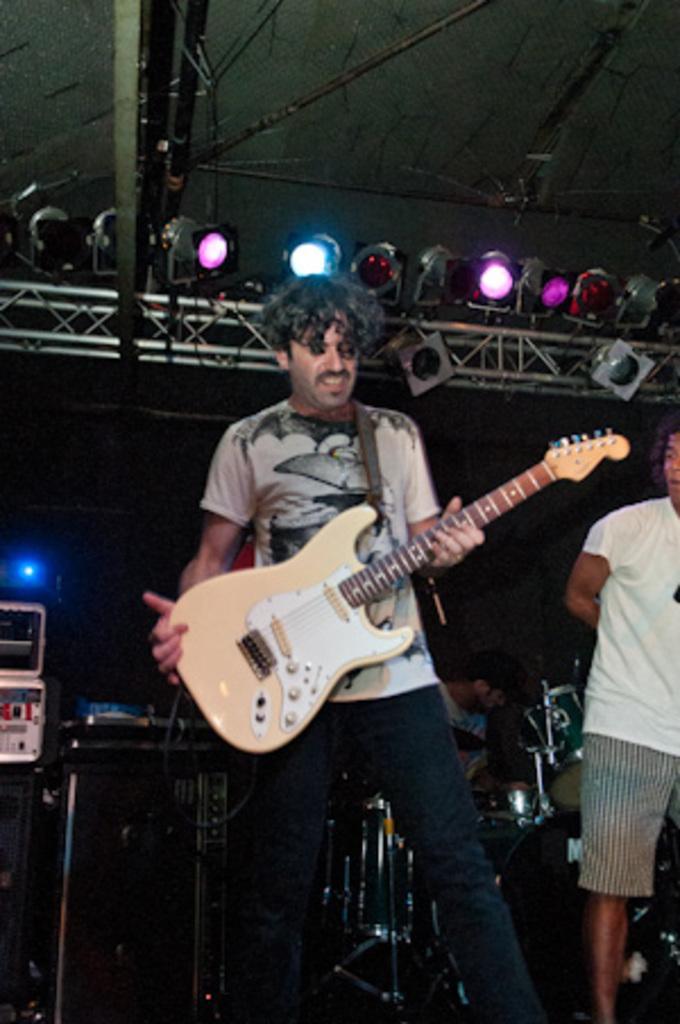Could you give a brief overview of what you see in this image? This man is standing and holding a guitar. Beside this person a person is standing. This person is sitting and playing this musical instruments. On top there are focusing lights. 